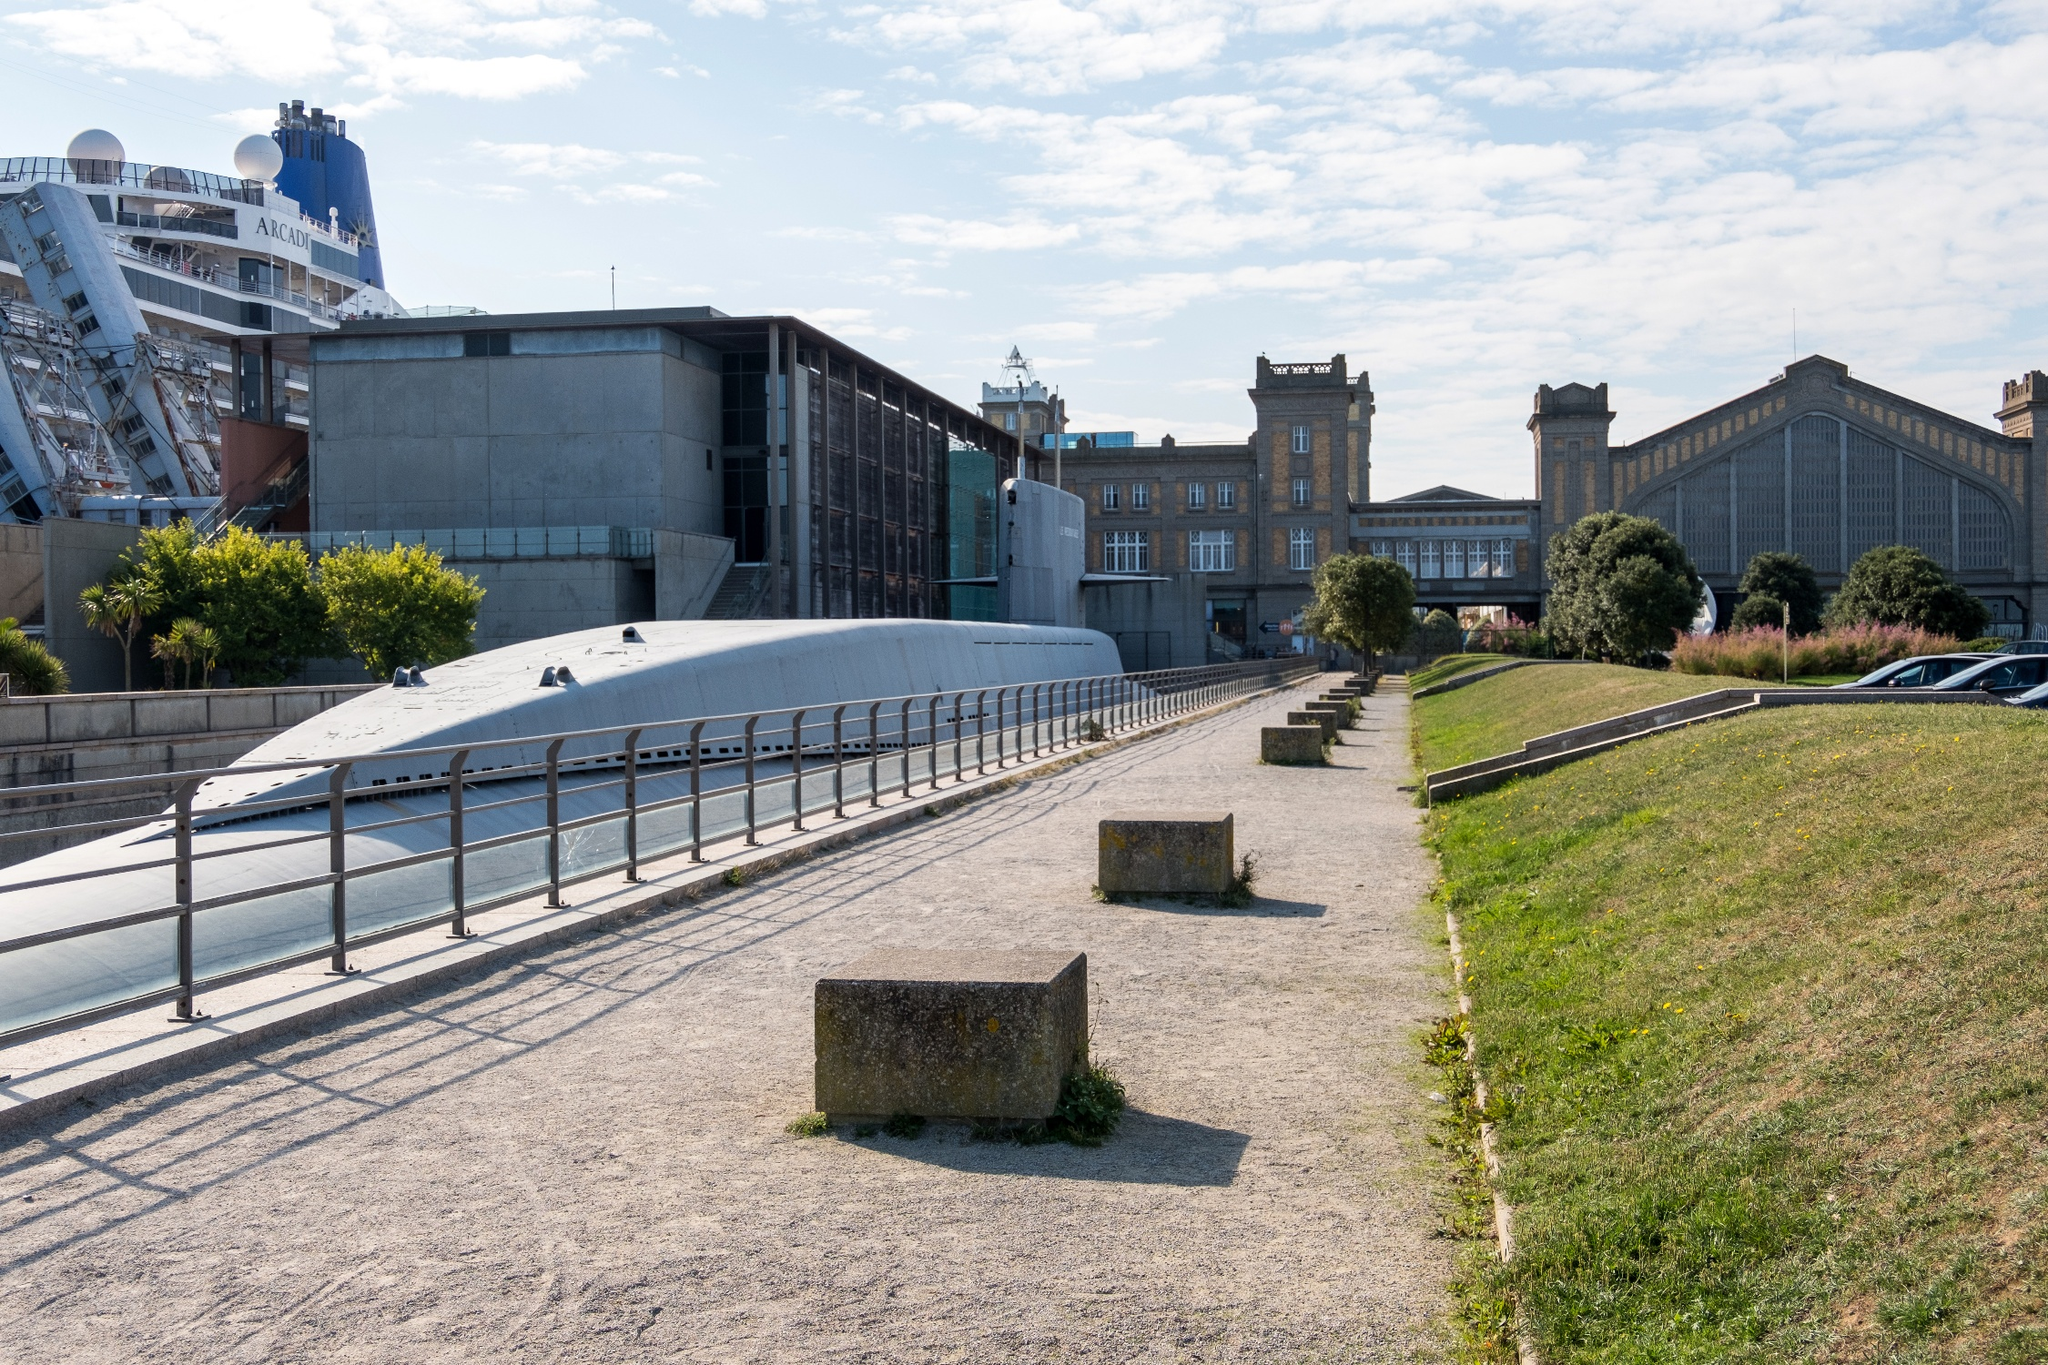What elements in the photo suggest it is Cherbourg-Octeville? The image suggests Cherbourg-Octeville through several key elements: the presence of the industrial and maritime buildings reflects the city's historical emphasis on port and shipbuilding activities. The blend of old and new architecture reflects the city's effort to preserve its heritage while embracing modernity. Finally, the docked cruise ship points to Cherbourg's role as a significant port city in Normandy, frequented by tourists and central to regional trade. 